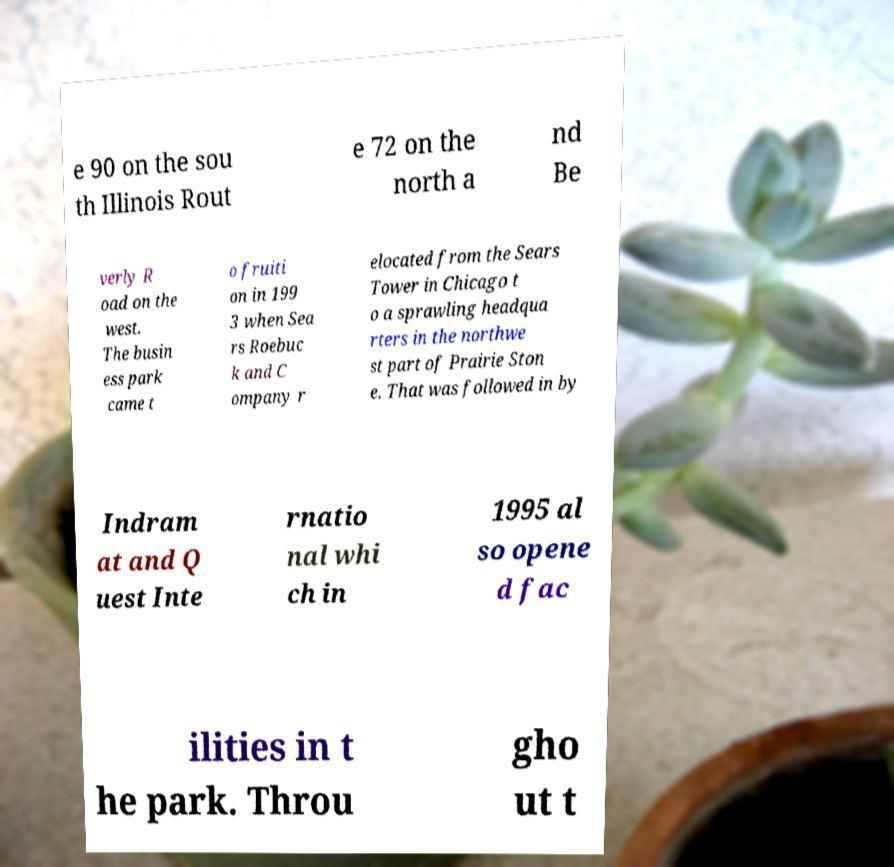I need the written content from this picture converted into text. Can you do that? e 90 on the sou th Illinois Rout e 72 on the north a nd Be verly R oad on the west. The busin ess park came t o fruiti on in 199 3 when Sea rs Roebuc k and C ompany r elocated from the Sears Tower in Chicago t o a sprawling headqua rters in the northwe st part of Prairie Ston e. That was followed in by Indram at and Q uest Inte rnatio nal whi ch in 1995 al so opene d fac ilities in t he park. Throu gho ut t 